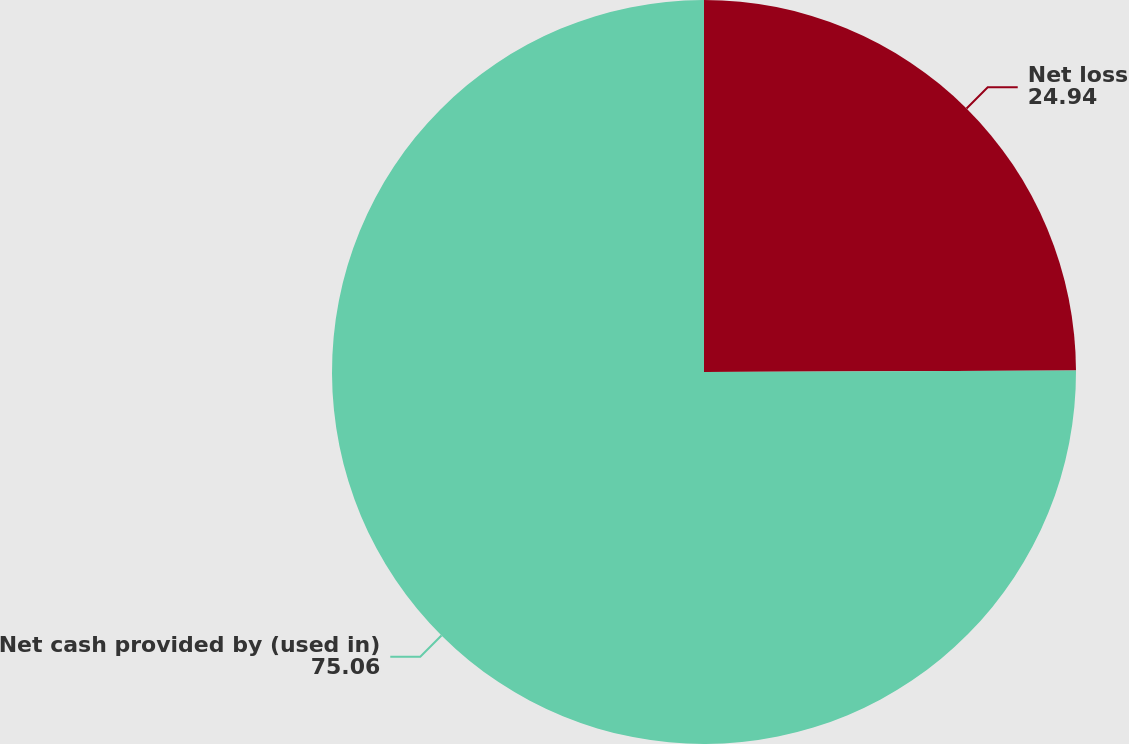Convert chart. <chart><loc_0><loc_0><loc_500><loc_500><pie_chart><fcel>Net loss<fcel>Net cash provided by (used in)<nl><fcel>24.94%<fcel>75.06%<nl></chart> 